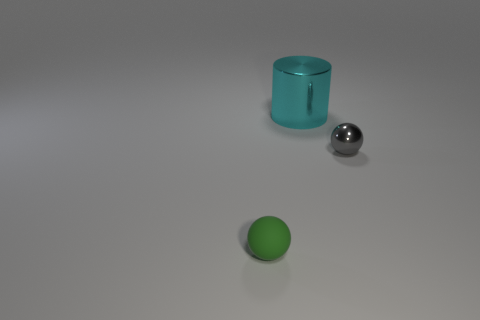Is there a tiny gray object that is on the right side of the large cyan shiny object on the left side of the small object that is to the right of the tiny green rubber sphere? yes 